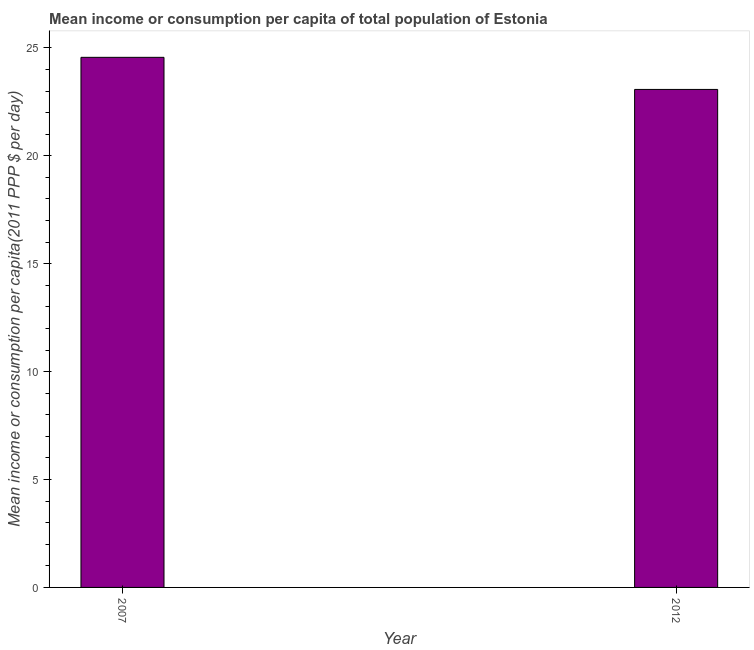What is the title of the graph?
Provide a succinct answer. Mean income or consumption per capita of total population of Estonia. What is the label or title of the X-axis?
Your answer should be compact. Year. What is the label or title of the Y-axis?
Ensure brevity in your answer.  Mean income or consumption per capita(2011 PPP $ per day). What is the mean income or consumption in 2012?
Offer a very short reply. 23.07. Across all years, what is the maximum mean income or consumption?
Ensure brevity in your answer.  24.56. Across all years, what is the minimum mean income or consumption?
Offer a terse response. 23.07. In which year was the mean income or consumption maximum?
Offer a terse response. 2007. In which year was the mean income or consumption minimum?
Your answer should be compact. 2012. What is the sum of the mean income or consumption?
Your answer should be very brief. 47.64. What is the difference between the mean income or consumption in 2007 and 2012?
Ensure brevity in your answer.  1.49. What is the average mean income or consumption per year?
Provide a succinct answer. 23.82. What is the median mean income or consumption?
Keep it short and to the point. 23.82. What is the ratio of the mean income or consumption in 2007 to that in 2012?
Ensure brevity in your answer.  1.06. Is the mean income or consumption in 2007 less than that in 2012?
Give a very brief answer. No. In how many years, is the mean income or consumption greater than the average mean income or consumption taken over all years?
Provide a succinct answer. 1. How many bars are there?
Ensure brevity in your answer.  2. Are all the bars in the graph horizontal?
Keep it short and to the point. No. How many years are there in the graph?
Offer a terse response. 2. What is the difference between two consecutive major ticks on the Y-axis?
Your answer should be compact. 5. Are the values on the major ticks of Y-axis written in scientific E-notation?
Make the answer very short. No. What is the Mean income or consumption per capita(2011 PPP $ per day) of 2007?
Provide a short and direct response. 24.56. What is the Mean income or consumption per capita(2011 PPP $ per day) in 2012?
Make the answer very short. 23.07. What is the difference between the Mean income or consumption per capita(2011 PPP $ per day) in 2007 and 2012?
Your answer should be very brief. 1.49. What is the ratio of the Mean income or consumption per capita(2011 PPP $ per day) in 2007 to that in 2012?
Your answer should be very brief. 1.06. 